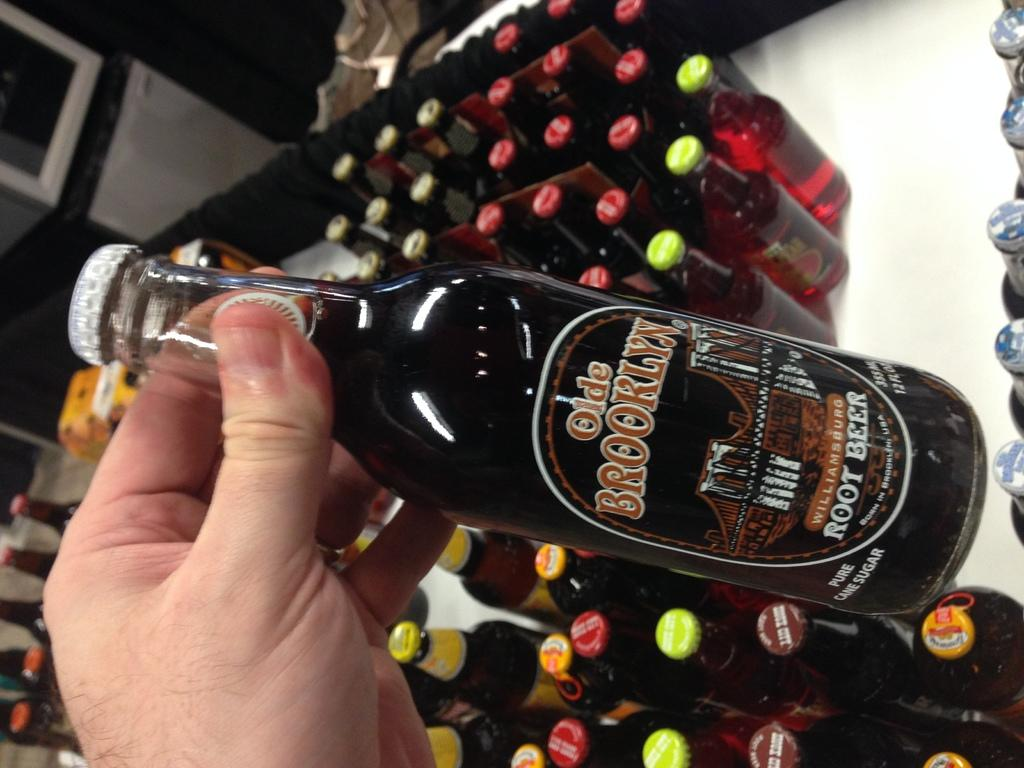<image>
Share a concise interpretation of the image provided. A bottle of Old Brooklyn Root Beer is being held above other bottles 